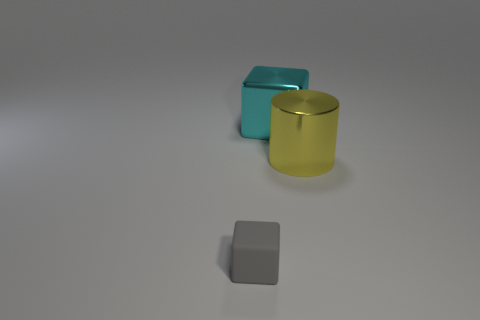Is the shape of the big yellow shiny thing the same as the big cyan object?
Provide a succinct answer. No. Is there anything else that has the same shape as the gray rubber object?
Your answer should be very brief. Yes. Are the cube behind the gray block and the tiny object made of the same material?
Give a very brief answer. No. There is a object that is to the left of the yellow cylinder and in front of the big cyan shiny cube; what shape is it?
Provide a succinct answer. Cube. Are there any large cyan blocks behind the big metallic object that is behind the yellow thing?
Provide a succinct answer. No. How many other objects are there of the same material as the tiny block?
Offer a terse response. 0. Do the object in front of the metal cylinder and the large metallic object that is in front of the big metallic cube have the same shape?
Your answer should be very brief. No. Is the material of the small thing the same as the large cyan thing?
Ensure brevity in your answer.  No. There is a shiny object that is to the right of the metal thing behind the metal object on the right side of the shiny block; how big is it?
Your answer should be very brief. Large. What number of other things are there of the same color as the metal block?
Make the answer very short. 0. 